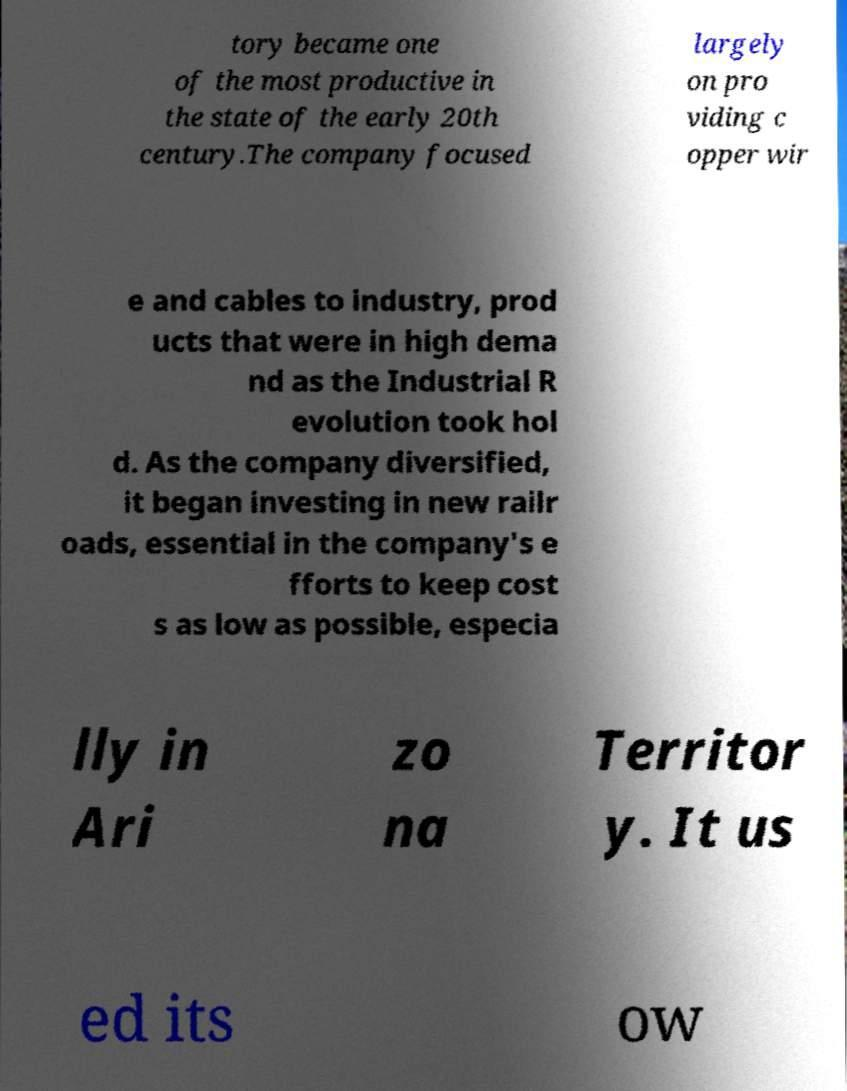Please read and relay the text visible in this image. What does it say? tory became one of the most productive in the state of the early 20th century.The company focused largely on pro viding c opper wir e and cables to industry, prod ucts that were in high dema nd as the Industrial R evolution took hol d. As the company diversified, it began investing in new railr oads, essential in the company's e fforts to keep cost s as low as possible, especia lly in Ari zo na Territor y. It us ed its ow 